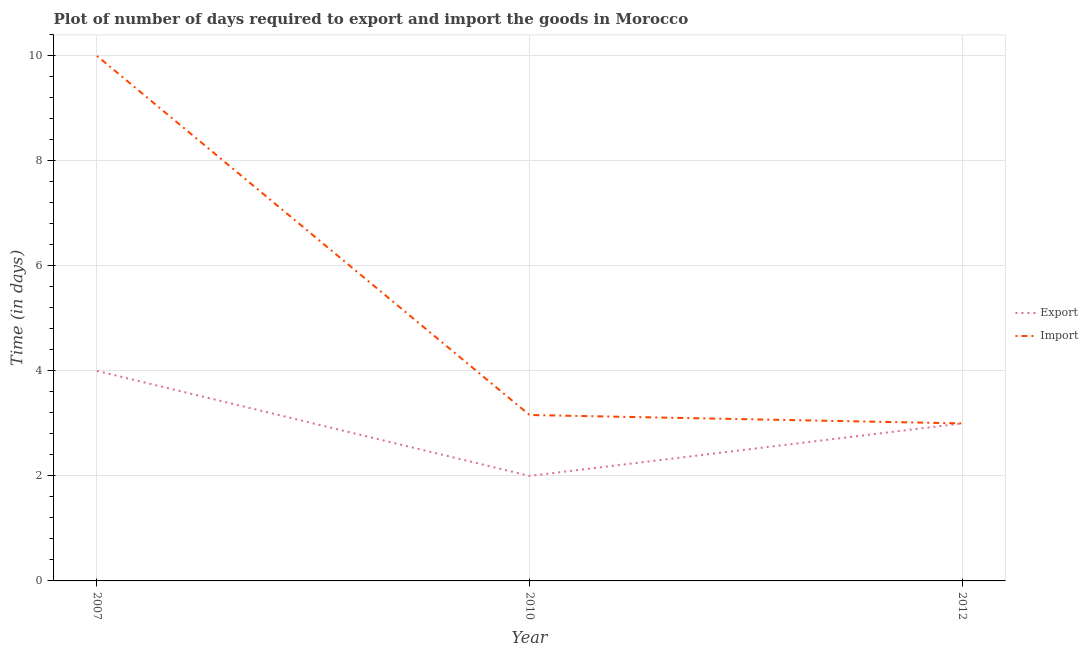Is the number of lines equal to the number of legend labels?
Keep it short and to the point. Yes. What is the time required to export in 2007?
Offer a very short reply. 4. Across all years, what is the maximum time required to export?
Ensure brevity in your answer.  4. Across all years, what is the minimum time required to import?
Make the answer very short. 3. In which year was the time required to export minimum?
Your answer should be very brief. 2010. What is the total time required to import in the graph?
Your answer should be very brief. 16.16. What is the difference between the time required to import in 2007 and that in 2010?
Give a very brief answer. 6.84. What is the difference between the time required to import in 2010 and the time required to export in 2007?
Your response must be concise. -0.84. What is the average time required to import per year?
Make the answer very short. 5.39. In the year 2012, what is the difference between the time required to import and time required to export?
Ensure brevity in your answer.  0. In how many years, is the time required to import greater than 9.2 days?
Offer a terse response. 1. What is the ratio of the time required to export in 2010 to that in 2012?
Provide a short and direct response. 0.67. Is the difference between the time required to import in 2010 and 2012 greater than the difference between the time required to export in 2010 and 2012?
Ensure brevity in your answer.  Yes. What is the difference between the highest and the lowest time required to export?
Offer a terse response. 2. Is the sum of the time required to export in 2007 and 2012 greater than the maximum time required to import across all years?
Your answer should be very brief. No. Does the time required to import monotonically increase over the years?
Your response must be concise. No. Is the time required to import strictly greater than the time required to export over the years?
Provide a short and direct response. No. Is the time required to import strictly less than the time required to export over the years?
Ensure brevity in your answer.  No. How many lines are there?
Ensure brevity in your answer.  2. How many years are there in the graph?
Offer a very short reply. 3. Are the values on the major ticks of Y-axis written in scientific E-notation?
Give a very brief answer. No. Does the graph contain any zero values?
Give a very brief answer. No. Does the graph contain grids?
Keep it short and to the point. Yes. Where does the legend appear in the graph?
Your answer should be very brief. Center right. How many legend labels are there?
Make the answer very short. 2. How are the legend labels stacked?
Offer a very short reply. Vertical. What is the title of the graph?
Make the answer very short. Plot of number of days required to export and import the goods in Morocco. Does "Working only" appear as one of the legend labels in the graph?
Offer a terse response. No. What is the label or title of the X-axis?
Provide a short and direct response. Year. What is the label or title of the Y-axis?
Keep it short and to the point. Time (in days). What is the Time (in days) of Import in 2007?
Give a very brief answer. 10. What is the Time (in days) in Export in 2010?
Provide a short and direct response. 2. What is the Time (in days) of Import in 2010?
Offer a terse response. 3.16. What is the Time (in days) of Export in 2012?
Your answer should be compact. 3. What is the Time (in days) of Import in 2012?
Your answer should be compact. 3. Across all years, what is the maximum Time (in days) of Import?
Offer a terse response. 10. Across all years, what is the minimum Time (in days) of Import?
Your answer should be very brief. 3. What is the total Time (in days) of Import in the graph?
Offer a terse response. 16.16. What is the difference between the Time (in days) of Export in 2007 and that in 2010?
Offer a very short reply. 2. What is the difference between the Time (in days) in Import in 2007 and that in 2010?
Keep it short and to the point. 6.84. What is the difference between the Time (in days) of Export in 2007 and that in 2012?
Provide a succinct answer. 1. What is the difference between the Time (in days) of Export in 2010 and that in 2012?
Give a very brief answer. -1. What is the difference between the Time (in days) of Import in 2010 and that in 2012?
Ensure brevity in your answer.  0.16. What is the difference between the Time (in days) in Export in 2007 and the Time (in days) in Import in 2010?
Provide a short and direct response. 0.84. What is the average Time (in days) in Import per year?
Provide a short and direct response. 5.39. In the year 2010, what is the difference between the Time (in days) of Export and Time (in days) of Import?
Make the answer very short. -1.16. In the year 2012, what is the difference between the Time (in days) in Export and Time (in days) in Import?
Keep it short and to the point. 0. What is the ratio of the Time (in days) of Import in 2007 to that in 2010?
Your response must be concise. 3.16. What is the ratio of the Time (in days) of Export in 2007 to that in 2012?
Provide a succinct answer. 1.33. What is the ratio of the Time (in days) in Export in 2010 to that in 2012?
Your response must be concise. 0.67. What is the ratio of the Time (in days) of Import in 2010 to that in 2012?
Keep it short and to the point. 1.05. What is the difference between the highest and the second highest Time (in days) in Import?
Your answer should be compact. 6.84. 